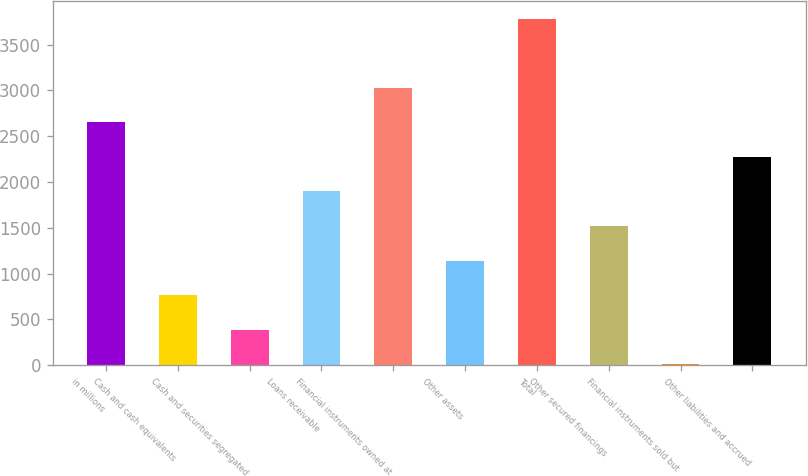<chart> <loc_0><loc_0><loc_500><loc_500><bar_chart><fcel>in millions<fcel>Cash and cash equivalents<fcel>Cash and securities segregated<fcel>Loans receivable<fcel>Financial instruments owned at<fcel>Other assets<fcel>Total<fcel>Other secured financings<fcel>Financial instruments sold but<fcel>Other liabilities and accrued<nl><fcel>2651.1<fcel>764.6<fcel>387.3<fcel>1896.5<fcel>3028.4<fcel>1141.9<fcel>3783<fcel>1519.2<fcel>10<fcel>2273.8<nl></chart> 